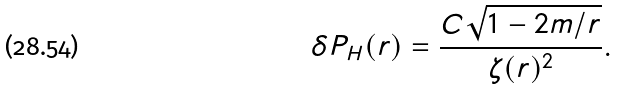Convert formula to latex. <formula><loc_0><loc_0><loc_500><loc_500>\delta P _ { H } ( r ) & = \frac { C \sqrt { 1 - 2 m / r } } { \zeta ( r ) ^ { 2 } } .</formula> 